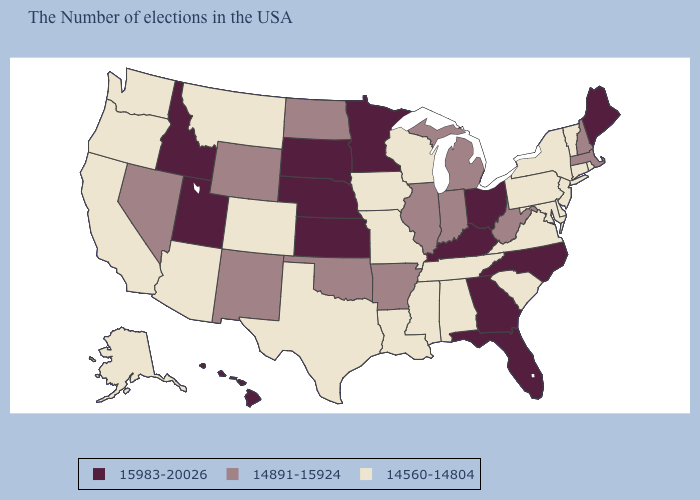What is the value of Michigan?
Concise answer only. 14891-15924. What is the highest value in states that border Nevada?
Short answer required. 15983-20026. What is the value of Hawaii?
Concise answer only. 15983-20026. What is the value of Washington?
Quick response, please. 14560-14804. Name the states that have a value in the range 14891-15924?
Quick response, please. Massachusetts, New Hampshire, West Virginia, Michigan, Indiana, Illinois, Arkansas, Oklahoma, North Dakota, Wyoming, New Mexico, Nevada. Does Nevada have the highest value in the West?
Answer briefly. No. What is the highest value in states that border North Dakota?
Write a very short answer. 15983-20026. What is the value of Nebraska?
Keep it brief. 15983-20026. Is the legend a continuous bar?
Quick response, please. No. What is the value of Louisiana?
Answer briefly. 14560-14804. Among the states that border Louisiana , does Mississippi have the highest value?
Answer briefly. No. Does New Hampshire have the lowest value in the USA?
Quick response, please. No. What is the value of Maryland?
Keep it brief. 14560-14804. Among the states that border Colorado , does Oklahoma have the highest value?
Short answer required. No. Does Louisiana have a higher value than Vermont?
Keep it brief. No. 